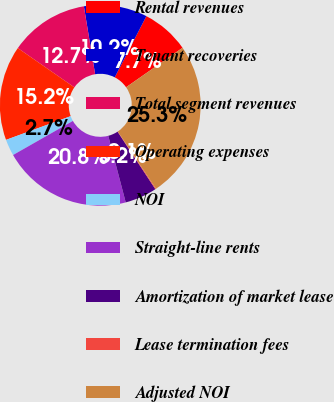Convert chart. <chart><loc_0><loc_0><loc_500><loc_500><pie_chart><fcel>Rental revenues<fcel>Tenant recoveries<fcel>Total segment revenues<fcel>Operating expenses<fcel>NOI<fcel>Straight-line rents<fcel>Amortization of market lease<fcel>Lease termination fees<fcel>Adjusted NOI<nl><fcel>7.69%<fcel>10.21%<fcel>12.73%<fcel>15.25%<fcel>2.65%<fcel>20.84%<fcel>5.17%<fcel>0.13%<fcel>25.33%<nl></chart> 